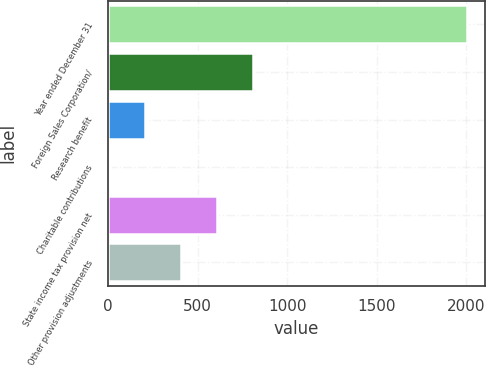<chart> <loc_0><loc_0><loc_500><loc_500><bar_chart><fcel>Year ended December 31<fcel>Foreign Sales Corporation/<fcel>Research benefit<fcel>Charitable contributions<fcel>State income tax provision net<fcel>Other provision adjustments<nl><fcel>2004<fcel>807<fcel>208.5<fcel>9<fcel>607.5<fcel>408<nl></chart> 